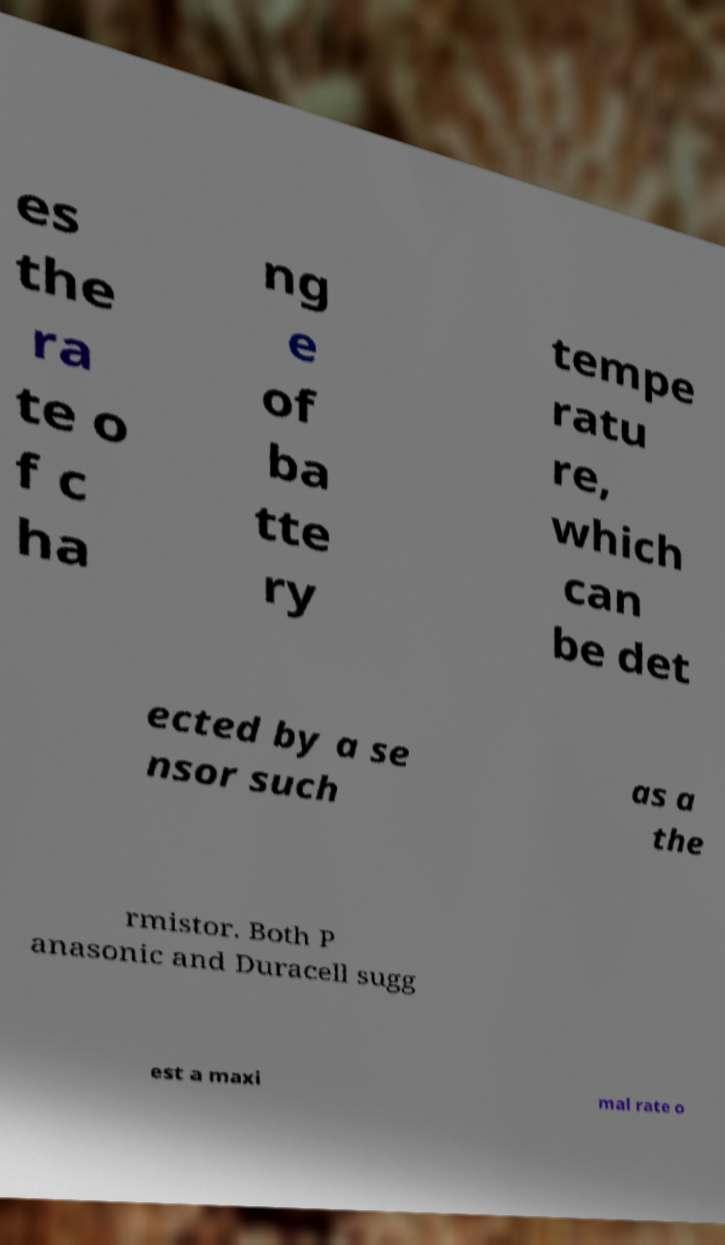What messages or text are displayed in this image? I need them in a readable, typed format. es the ra te o f c ha ng e of ba tte ry tempe ratu re, which can be det ected by a se nsor such as a the rmistor. Both P anasonic and Duracell sugg est a maxi mal rate o 